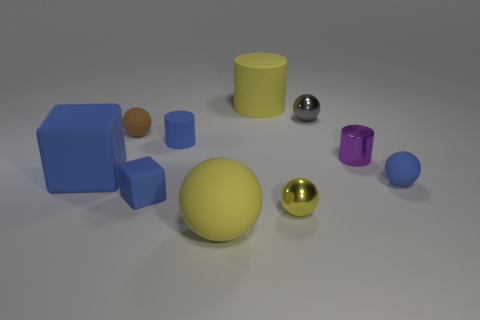Subtract all blue rubber spheres. How many spheres are left? 4 Subtract all blue balls. How many balls are left? 4 Subtract all red balls. Subtract all red cylinders. How many balls are left? 5 Subtract all big spheres. Subtract all tiny gray things. How many objects are left? 8 Add 8 large blue things. How many large blue things are left? 9 Add 2 large yellow balls. How many large yellow balls exist? 3 Subtract 0 brown cylinders. How many objects are left? 10 Subtract all cylinders. How many objects are left? 7 